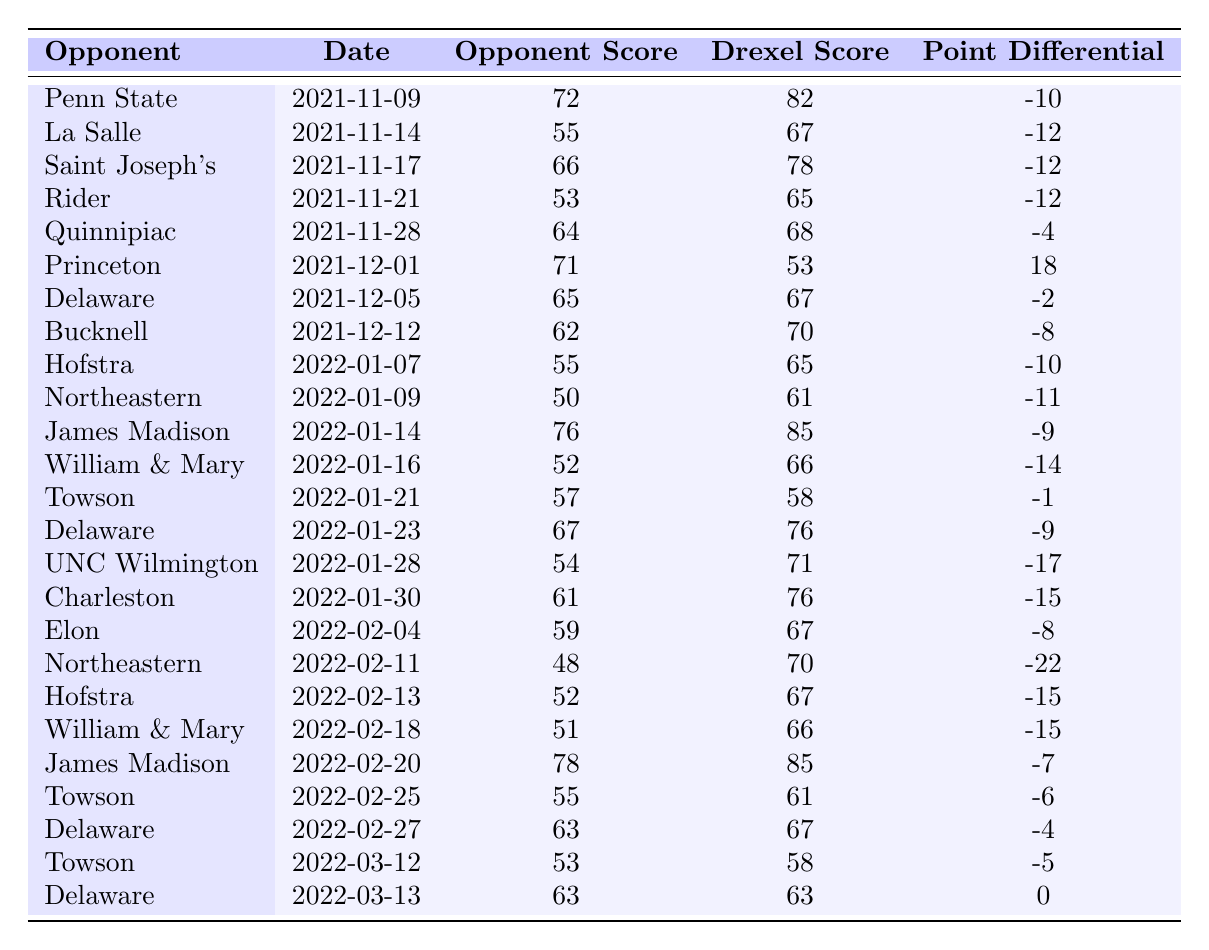What was the highest score by an opponent against the Drexel Dragons? By examining the "Opponent Score" column, the highest score is 78, which occurred against James Madison on two different occasions (2022-01-14 and 2022-02-20).
Answer: 78 How many teams scored less than 60 points against the Drexel Dragons? Counting the "Opponent Score" values that are less than 60, we find that four teams (Rider, Northeastern, Hofstra, and William & Mary) scored less than 60 points.
Answer: 4 What was the point differential in the game against Princeton? The "Point Differential" for the game against Princeton is 18, as indicated in the corresponding row of the table.
Answer: 18 Did any opponent score the same number of points as Drexel in a game? Yes, in the game against Delaware on March 13, both teams scored 63 points.
Answer: Yes What is the average score of the opponents against the Drexel Dragons? To find the average, sum all the "Opponent Score" values (a total of 66) and divide by the number of games (27), which is 62.37 rounded to two decimal places.
Answer: 62.37 Which opponent had the largest negative point differential against the Drexel Dragons? The game with the largest negative point differential was against Northeastern on 2022-02-11, with a differential of -22.
Answer: Northeastern How many games did the Drexel Dragons score more than 70 points? The Drexel Dragons scored more than 70 points in nine separate games, as listed in the "Drexel Score" column.
Answer: 9 In how many games did Drexel win by more than 10 points? by checking the "Point Differential" column, the games where the differential is greater than 10 are against Penn State and Princeton (both winning games), resulting in a total of two games.
Answer: 2 What is the total number of points scored by all opponents throughout the season? Summing all the "Opponent Score" values gives a total of 1,644 points scored by the opponents over the course of the season.
Answer: 1644 How many times did the Drexel Dragons lose by a point differential of three or fewer? When looking through the "Point Differential" values, games where the point differential is -3 or better count as three times (against Delaware, Towson, and the last game against Delaware).
Answer: 3 